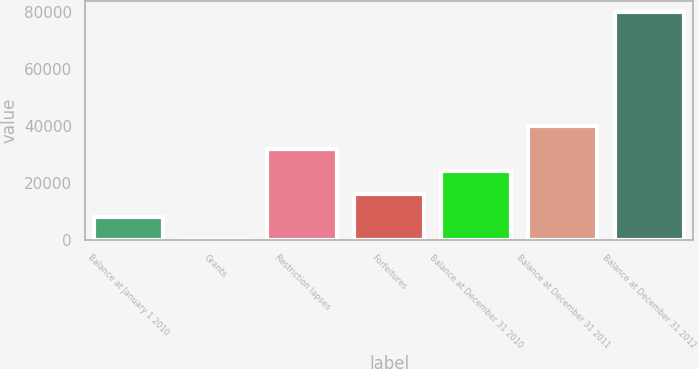Convert chart to OTSL. <chart><loc_0><loc_0><loc_500><loc_500><bar_chart><fcel>Balance at January 1 2010<fcel>Grants<fcel>Restriction lapses<fcel>Forfeitures<fcel>Balance at December 31 2010<fcel>Balance at December 31 2011<fcel>Balance at December 31 2012<nl><fcel>8001.54<fcel>1.71<fcel>32001<fcel>16001.4<fcel>24001.2<fcel>40000.9<fcel>80000<nl></chart> 